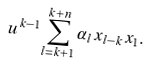Convert formula to latex. <formula><loc_0><loc_0><loc_500><loc_500>u ^ { k - 1 } \sum _ { l = k + 1 } ^ { k + n } \alpha _ { l } x _ { l - k } x _ { 1 } .</formula> 